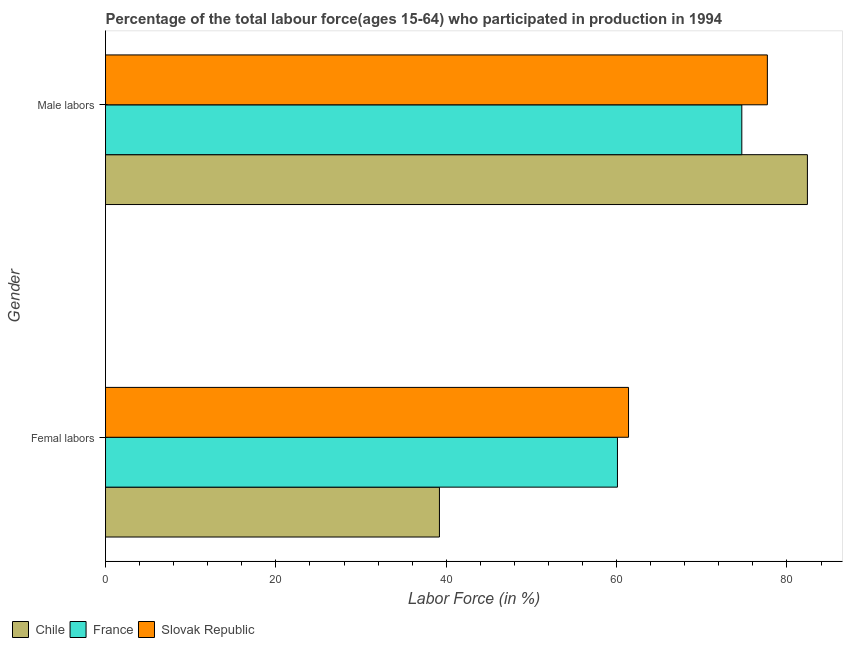How many groups of bars are there?
Keep it short and to the point. 2. Are the number of bars per tick equal to the number of legend labels?
Provide a short and direct response. Yes. How many bars are there on the 1st tick from the top?
Provide a succinct answer. 3. What is the label of the 2nd group of bars from the top?
Your answer should be very brief. Femal labors. What is the percentage of male labour force in Chile?
Provide a succinct answer. 82.4. Across all countries, what is the maximum percentage of male labour force?
Ensure brevity in your answer.  82.4. Across all countries, what is the minimum percentage of male labour force?
Ensure brevity in your answer.  74.7. In which country was the percentage of male labour force maximum?
Your answer should be very brief. Chile. In which country was the percentage of male labour force minimum?
Provide a short and direct response. France. What is the total percentage of female labor force in the graph?
Offer a very short reply. 160.7. What is the difference between the percentage of female labor force in France and that in Slovak Republic?
Provide a succinct answer. -1.3. What is the difference between the percentage of male labour force in France and the percentage of female labor force in Slovak Republic?
Your answer should be very brief. 13.3. What is the average percentage of female labor force per country?
Ensure brevity in your answer.  53.57. What is the difference between the percentage of female labor force and percentage of male labour force in France?
Your answer should be very brief. -14.6. In how many countries, is the percentage of female labor force greater than 32 %?
Provide a succinct answer. 3. What is the ratio of the percentage of male labour force in Chile to that in France?
Make the answer very short. 1.1. Is the percentage of male labour force in Slovak Republic less than that in France?
Provide a succinct answer. No. What does the 2nd bar from the top in Male labors represents?
Offer a very short reply. France. What does the 3rd bar from the bottom in Male labors represents?
Keep it short and to the point. Slovak Republic. How many bars are there?
Your answer should be compact. 6. Are all the bars in the graph horizontal?
Keep it short and to the point. Yes. Where does the legend appear in the graph?
Give a very brief answer. Bottom left. How are the legend labels stacked?
Your response must be concise. Horizontal. What is the title of the graph?
Provide a succinct answer. Percentage of the total labour force(ages 15-64) who participated in production in 1994. What is the label or title of the Y-axis?
Your answer should be compact. Gender. What is the Labor Force (in %) in Chile in Femal labors?
Make the answer very short. 39.2. What is the Labor Force (in %) in France in Femal labors?
Your answer should be very brief. 60.1. What is the Labor Force (in %) of Slovak Republic in Femal labors?
Give a very brief answer. 61.4. What is the Labor Force (in %) of Chile in Male labors?
Provide a short and direct response. 82.4. What is the Labor Force (in %) of France in Male labors?
Provide a short and direct response. 74.7. What is the Labor Force (in %) in Slovak Republic in Male labors?
Provide a short and direct response. 77.7. Across all Gender, what is the maximum Labor Force (in %) of Chile?
Keep it short and to the point. 82.4. Across all Gender, what is the maximum Labor Force (in %) of France?
Provide a short and direct response. 74.7. Across all Gender, what is the maximum Labor Force (in %) in Slovak Republic?
Make the answer very short. 77.7. Across all Gender, what is the minimum Labor Force (in %) in Chile?
Provide a short and direct response. 39.2. Across all Gender, what is the minimum Labor Force (in %) of France?
Keep it short and to the point. 60.1. Across all Gender, what is the minimum Labor Force (in %) of Slovak Republic?
Make the answer very short. 61.4. What is the total Labor Force (in %) of Chile in the graph?
Offer a terse response. 121.6. What is the total Labor Force (in %) in France in the graph?
Give a very brief answer. 134.8. What is the total Labor Force (in %) of Slovak Republic in the graph?
Your answer should be compact. 139.1. What is the difference between the Labor Force (in %) in Chile in Femal labors and that in Male labors?
Provide a short and direct response. -43.2. What is the difference between the Labor Force (in %) of France in Femal labors and that in Male labors?
Provide a succinct answer. -14.6. What is the difference between the Labor Force (in %) of Slovak Republic in Femal labors and that in Male labors?
Ensure brevity in your answer.  -16.3. What is the difference between the Labor Force (in %) of Chile in Femal labors and the Labor Force (in %) of France in Male labors?
Provide a succinct answer. -35.5. What is the difference between the Labor Force (in %) of Chile in Femal labors and the Labor Force (in %) of Slovak Republic in Male labors?
Ensure brevity in your answer.  -38.5. What is the difference between the Labor Force (in %) in France in Femal labors and the Labor Force (in %) in Slovak Republic in Male labors?
Offer a terse response. -17.6. What is the average Labor Force (in %) in Chile per Gender?
Your response must be concise. 60.8. What is the average Labor Force (in %) of France per Gender?
Your response must be concise. 67.4. What is the average Labor Force (in %) of Slovak Republic per Gender?
Provide a succinct answer. 69.55. What is the difference between the Labor Force (in %) of Chile and Labor Force (in %) of France in Femal labors?
Ensure brevity in your answer.  -20.9. What is the difference between the Labor Force (in %) in Chile and Labor Force (in %) in Slovak Republic in Femal labors?
Your answer should be very brief. -22.2. What is the difference between the Labor Force (in %) of France and Labor Force (in %) of Slovak Republic in Femal labors?
Your answer should be very brief. -1.3. What is the difference between the Labor Force (in %) of Chile and Labor Force (in %) of France in Male labors?
Your response must be concise. 7.7. What is the difference between the Labor Force (in %) in France and Labor Force (in %) in Slovak Republic in Male labors?
Keep it short and to the point. -3. What is the ratio of the Labor Force (in %) in Chile in Femal labors to that in Male labors?
Provide a succinct answer. 0.48. What is the ratio of the Labor Force (in %) of France in Femal labors to that in Male labors?
Keep it short and to the point. 0.8. What is the ratio of the Labor Force (in %) of Slovak Republic in Femal labors to that in Male labors?
Offer a very short reply. 0.79. What is the difference between the highest and the second highest Labor Force (in %) of Chile?
Keep it short and to the point. 43.2. What is the difference between the highest and the lowest Labor Force (in %) in Chile?
Keep it short and to the point. 43.2. 